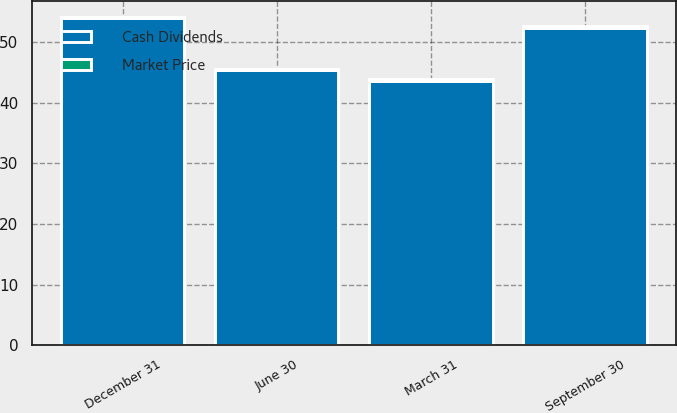Convert chart. <chart><loc_0><loc_0><loc_500><loc_500><stacked_bar_chart><ecel><fcel>December 31<fcel>September 30<fcel>June 30<fcel>March 31<nl><fcel>Cash Dividends<fcel>53.91<fcel>52.36<fcel>45.4<fcel>43.6<nl><fcel>Market Price<fcel>0.24<fcel>0.24<fcel>0.24<fcel>0.24<nl></chart> 